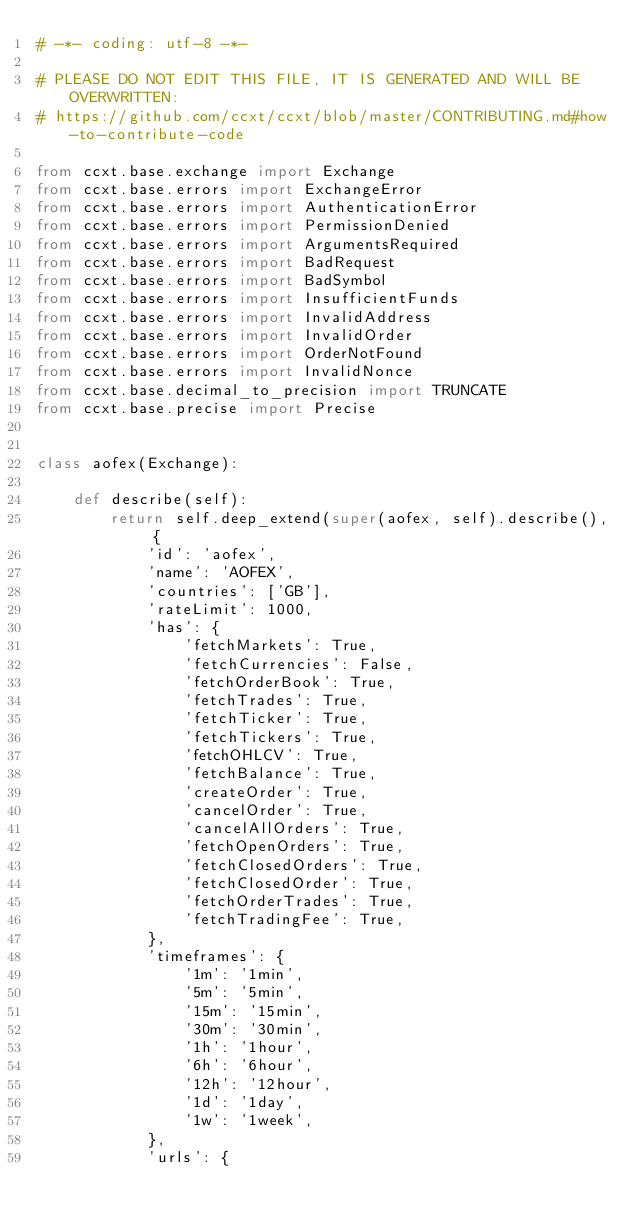<code> <loc_0><loc_0><loc_500><loc_500><_Python_># -*- coding: utf-8 -*-

# PLEASE DO NOT EDIT THIS FILE, IT IS GENERATED AND WILL BE OVERWRITTEN:
# https://github.com/ccxt/ccxt/blob/master/CONTRIBUTING.md#how-to-contribute-code

from ccxt.base.exchange import Exchange
from ccxt.base.errors import ExchangeError
from ccxt.base.errors import AuthenticationError
from ccxt.base.errors import PermissionDenied
from ccxt.base.errors import ArgumentsRequired
from ccxt.base.errors import BadRequest
from ccxt.base.errors import BadSymbol
from ccxt.base.errors import InsufficientFunds
from ccxt.base.errors import InvalidAddress
from ccxt.base.errors import InvalidOrder
from ccxt.base.errors import OrderNotFound
from ccxt.base.errors import InvalidNonce
from ccxt.base.decimal_to_precision import TRUNCATE
from ccxt.base.precise import Precise


class aofex(Exchange):

    def describe(self):
        return self.deep_extend(super(aofex, self).describe(), {
            'id': 'aofex',
            'name': 'AOFEX',
            'countries': ['GB'],
            'rateLimit': 1000,
            'has': {
                'fetchMarkets': True,
                'fetchCurrencies': False,
                'fetchOrderBook': True,
                'fetchTrades': True,
                'fetchTicker': True,
                'fetchTickers': True,
                'fetchOHLCV': True,
                'fetchBalance': True,
                'createOrder': True,
                'cancelOrder': True,
                'cancelAllOrders': True,
                'fetchOpenOrders': True,
                'fetchClosedOrders': True,
                'fetchClosedOrder': True,
                'fetchOrderTrades': True,
                'fetchTradingFee': True,
            },
            'timeframes': {
                '1m': '1min',
                '5m': '5min',
                '15m': '15min',
                '30m': '30min',
                '1h': '1hour',
                '6h': '6hour',
                '12h': '12hour',
                '1d': '1day',
                '1w': '1week',
            },
            'urls': {</code> 